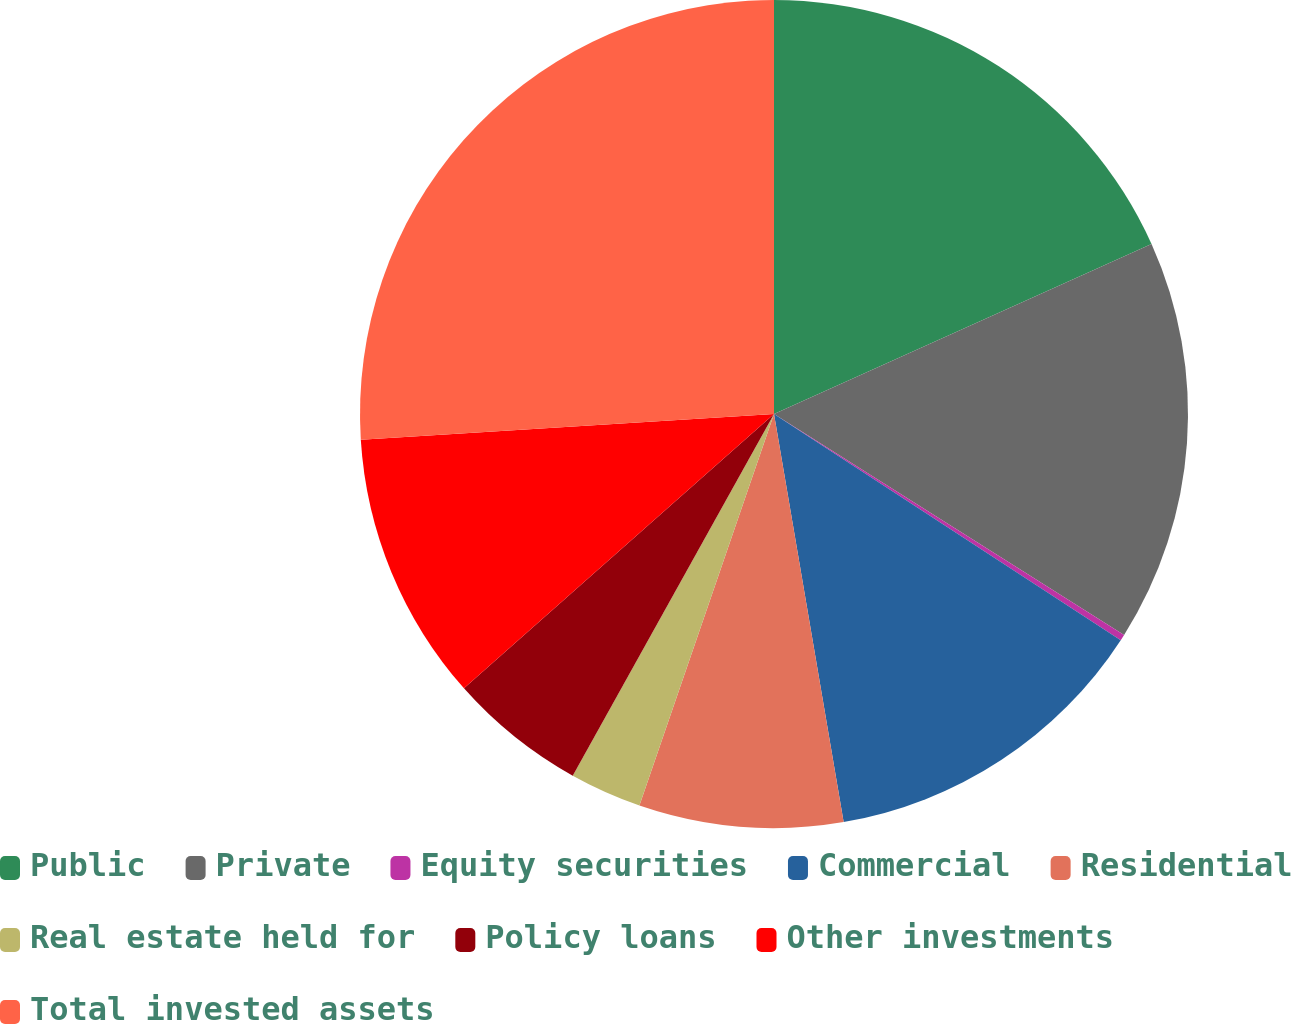Convert chart. <chart><loc_0><loc_0><loc_500><loc_500><pie_chart><fcel>Public<fcel>Private<fcel>Equity securities<fcel>Commercial<fcel>Residential<fcel>Real estate held for<fcel>Policy loans<fcel>Other investments<fcel>Total invested assets<nl><fcel>18.27%<fcel>15.69%<fcel>0.24%<fcel>13.11%<fcel>7.96%<fcel>2.81%<fcel>5.39%<fcel>10.54%<fcel>25.99%<nl></chart> 